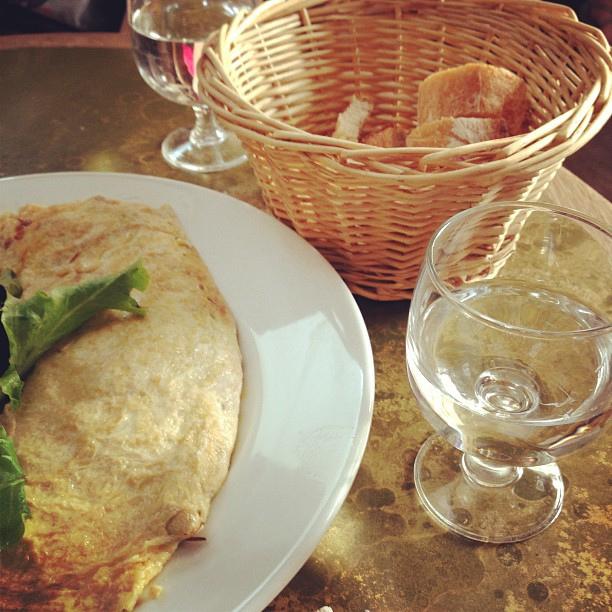Is the glass half full or half empty?
Quick response, please. Half full. What is in the basket?
Answer briefly. Bread. What is the table made out of?
Answer briefly. Stone. 